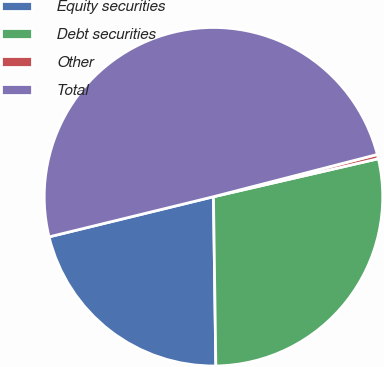<chart> <loc_0><loc_0><loc_500><loc_500><pie_chart><fcel>Equity securities<fcel>Debt securities<fcel>Other<fcel>Total<nl><fcel>21.41%<fcel>28.38%<fcel>0.41%<fcel>49.79%<nl></chart> 